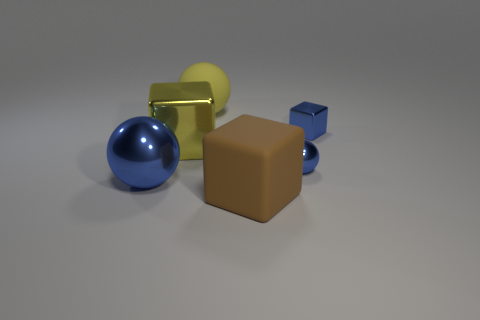Subtract all blue shiny balls. How many balls are left? 1 Add 4 yellow objects. How many objects exist? 10 Subtract 1 blue balls. How many objects are left? 5 Subtract all big yellow things. Subtract all big metallic cubes. How many objects are left? 3 Add 4 big yellow objects. How many big yellow objects are left? 6 Add 5 tiny red objects. How many tiny red objects exist? 5 